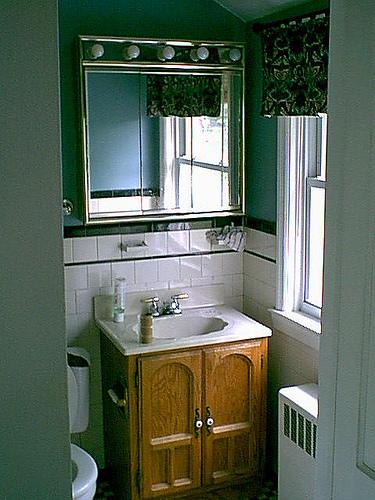What is reflected in the mirror?
Short answer required. Window. Is the light on?
Answer briefly. No. How many windows are in this room?
Quick response, please. 1. Is there a vanity in the bathroom?
Give a very brief answer. Yes. Whose bathroom is this?
Keep it brief. Person. What is on the countertops?
Give a very brief answer. Soap. How many light bulbs are above the mirror?
Answer briefly. 5. What room is this?
Be succinct. Bathroom. Which room of the house is this?
Concise answer only. Bathroom. 